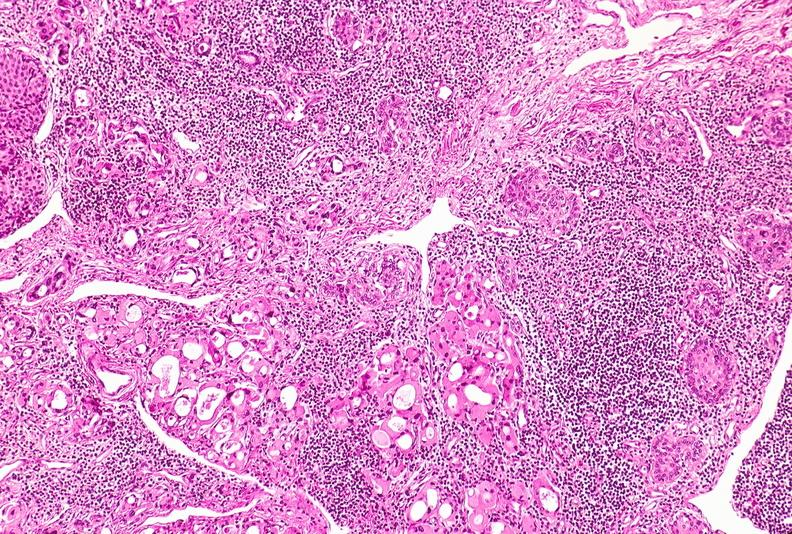where is this part in the figure?
Answer the question using a single word or phrase. Endocrine system 